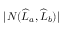<formula> <loc_0><loc_0><loc_500><loc_500>| N ( \widehat { L } _ { a } , \widehat { L } _ { b } ) |</formula> 